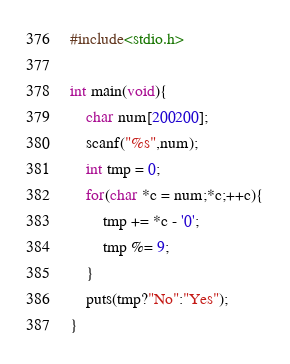Convert code to text. <code><loc_0><loc_0><loc_500><loc_500><_C_>#include<stdio.h>

int main(void){
    char num[200200];
    scanf("%s",num);
    int tmp = 0;
    for(char *c = num;*c;++c){
        tmp += *c - '0';
        tmp %= 9;
    }
    puts(tmp?"No":"Yes");
}</code> 